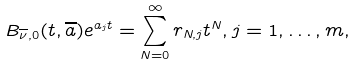Convert formula to latex. <formula><loc_0><loc_0><loc_500><loc_500>B _ { \overline { \nu } , 0 } ( t , \overline { a } ) e ^ { a _ { j } t } = \sum _ { N = 0 } ^ { \infty } r _ { N , j } t ^ { N } , j = 1 , \dots , m ,</formula> 